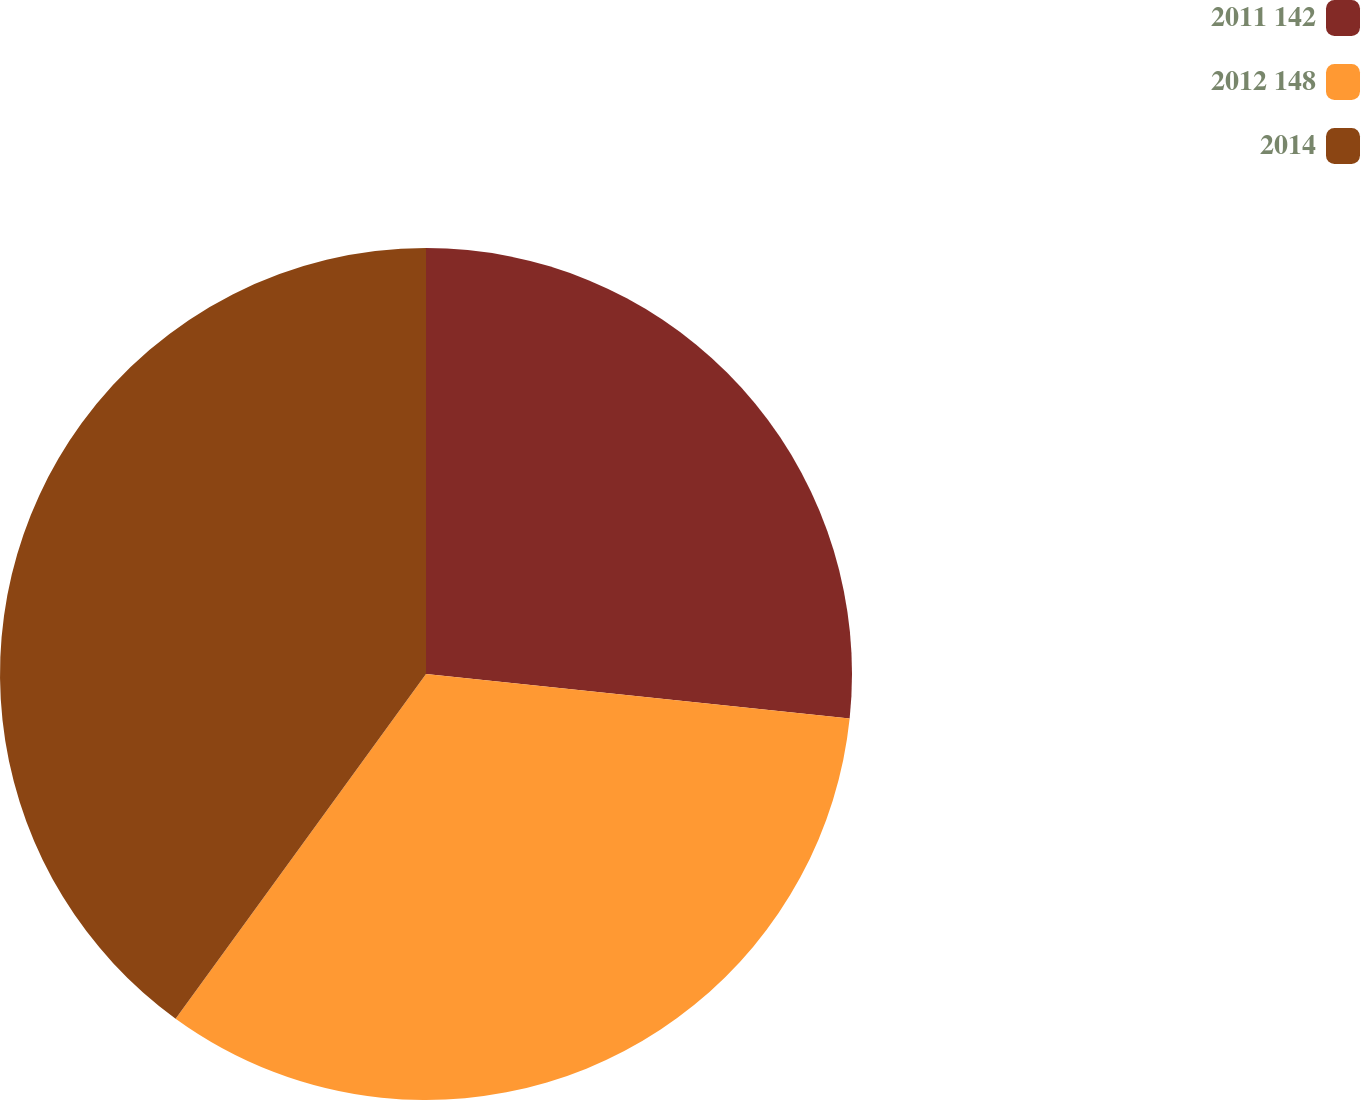Convert chart. <chart><loc_0><loc_0><loc_500><loc_500><pie_chart><fcel>2011 142<fcel>2012 148<fcel>2014<nl><fcel>26.67%<fcel>33.33%<fcel>40.0%<nl></chart> 